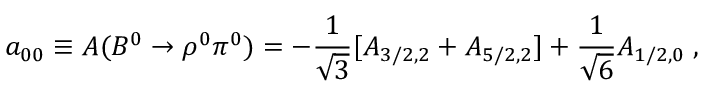Convert formula to latex. <formula><loc_0><loc_0><loc_500><loc_500>a _ { 0 0 } \equiv A ( B ^ { 0 } \to \rho ^ { 0 } \pi ^ { 0 } ) = - \frac { 1 } { \sqrt { 3 } } [ A _ { 3 / 2 , 2 } + A _ { 5 / 2 , 2 } ] + \frac { 1 } { \sqrt { 6 } } A _ { 1 / 2 , 0 } \, ,</formula> 